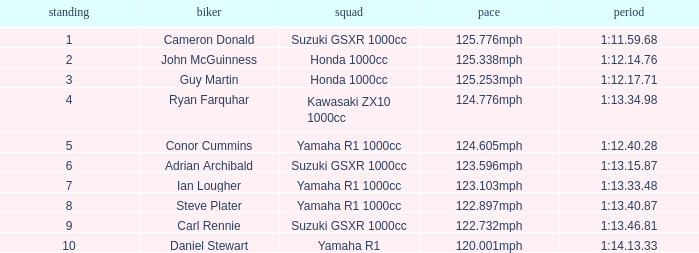What time did team kawasaki zx10 1000cc have? 1:13.34.98. 